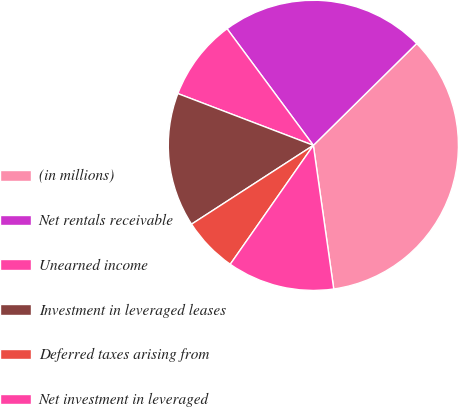<chart> <loc_0><loc_0><loc_500><loc_500><pie_chart><fcel>(in millions)<fcel>Net rentals receivable<fcel>Unearned income<fcel>Investment in leveraged leases<fcel>Deferred taxes arising from<fcel>Net investment in leveraged<nl><fcel>35.14%<fcel>22.75%<fcel>9.05%<fcel>14.95%<fcel>6.15%<fcel>11.95%<nl></chart> 